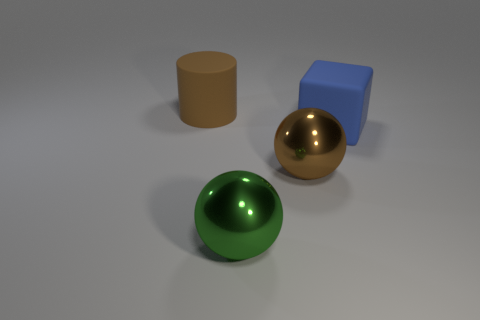Are any green metal cubes visible?
Your response must be concise. No. There is a large rubber thing that is in front of the large rubber thing that is on the left side of the large blue cube; are there any cubes that are on the right side of it?
Provide a short and direct response. No. What number of big objects are shiny things or yellow matte balls?
Give a very brief answer. 2. What color is the cube that is the same size as the brown matte object?
Offer a terse response. Blue. There is a big green thing; what number of large green metallic balls are to the right of it?
Make the answer very short. 0. Are there any large gray spheres that have the same material as the brown cylinder?
Provide a succinct answer. No. What shape is the big metal object that is the same color as the big matte cylinder?
Your answer should be compact. Sphere. What is the color of the object behind the blue cube?
Make the answer very short. Brown. Are there the same number of cylinders to the left of the blue thing and large matte blocks to the right of the brown sphere?
Your answer should be very brief. Yes. There is a large brown thing to the left of the metal thing to the right of the green object; what is its material?
Your answer should be compact. Rubber. 